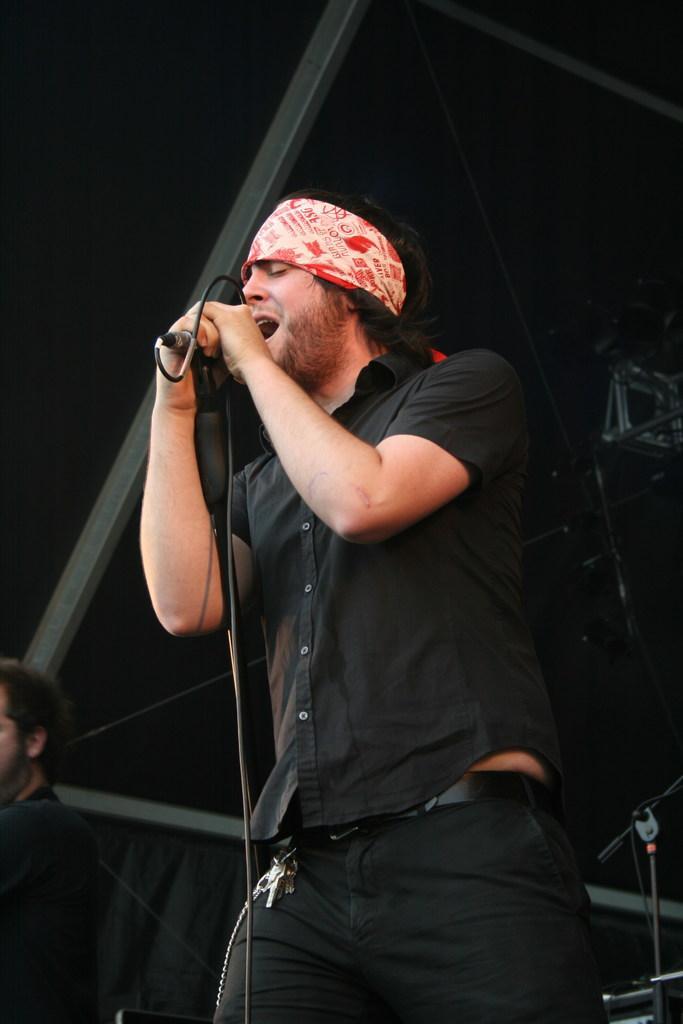Describe this image in one or two sentences. A person is standing and singing on the microphone,beside him there is another person. 